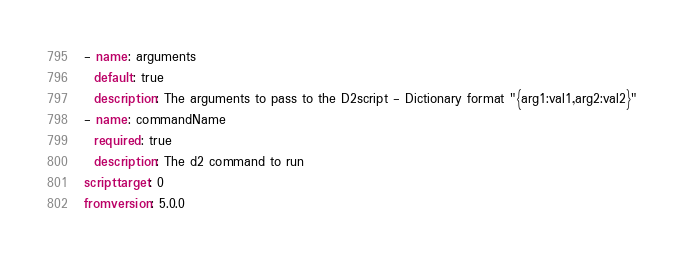Convert code to text. <code><loc_0><loc_0><loc_500><loc_500><_YAML_>- name: arguments
  default: true
  description: The arguments to pass to the D2script - Dictionary format "{arg1:val1,arg2:val2}"
- name: commandName
  required: true
  description: The d2 command to run
scripttarget: 0
fromversion: 5.0.0
</code> 